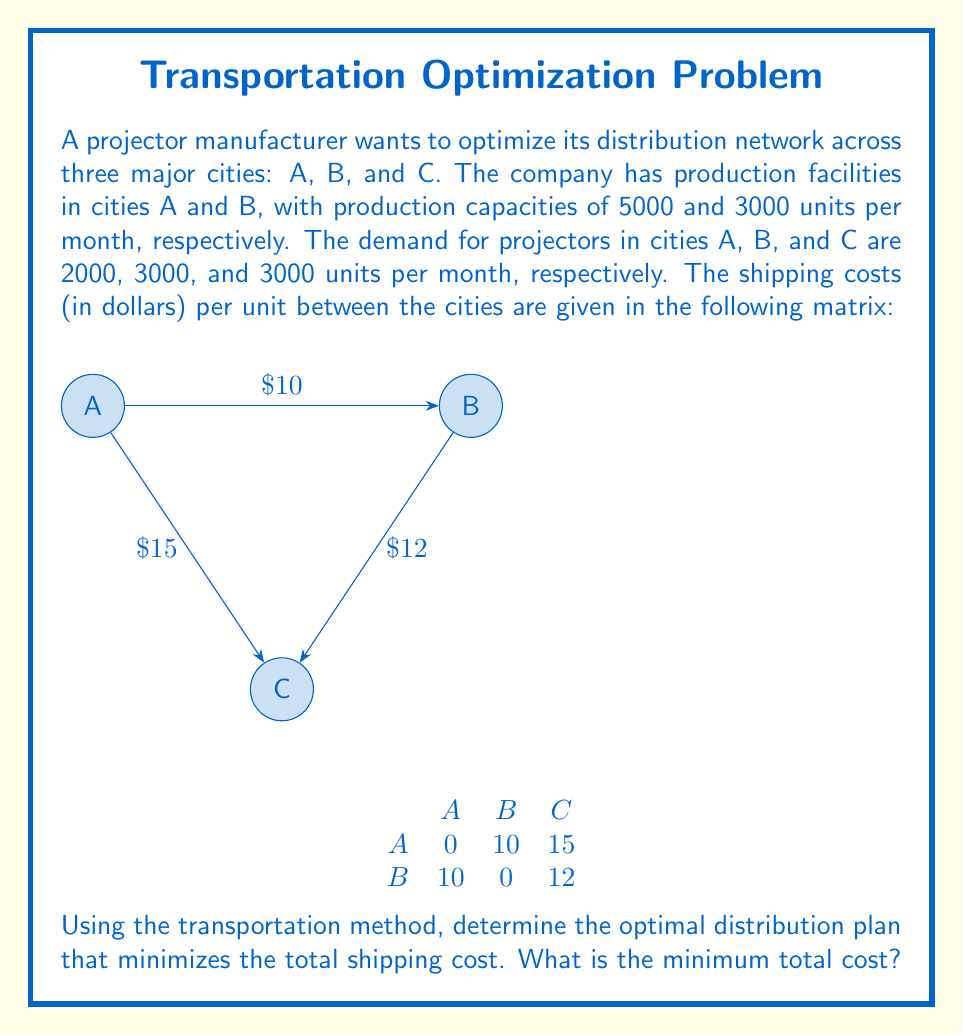Give your solution to this math problem. To solve this problem, we'll use the transportation method, which is a linear programming technique. Let's follow these steps:

1) First, let's set up the initial transportation table:

   $$
   \begin{array}{c|ccc|c}
    & A & B & C & \text{Supply} \\
   \hline
   A & 0 & 10 & 15 & 5000 \\
   B & 10 & 0 & 12 & 3000 \\
   \hline
   \text{Demand} & 2000 & 3000 & 3000 & 8000
   \end{array}
   $$

2) We'll use the Northwest Corner method to find an initial feasible solution:

   $$
   \begin{array}{c|ccc|c}
    & A & B & C & \text{Supply} \\
   \hline
   A & 2000 & 3000 & 0 & 5000 \\
   B & 0 & 0 & 3000 & 3000 \\
   \hline
   \text{Demand} & 2000 & 3000 & 3000 & 8000
   \end{array}
   $$

3) Now, let's calculate the initial cost:
   $2000 \times 0 + 3000 \times 10 + 3000 \times 12 = 66,000$

4) Next, we need to check if this solution is optimal. We'll use the stepping stone method:
   - Calculate ui and vj values
   - Find the opportunity cost for empty cells

5) After calculations, we find that the cell B to A has a negative opportunity cost of -10. This means we can improve the solution.

6) We make the following adjustment:
   - Add 2000 to B to A
   - Subtract 2000 from A to A
   - Add 2000 to A to C
   - Subtract 2000 from B to C

7) Our new solution looks like this:

   $$
   \begin{array}{c|ccc|c}
    & A & B & C & \text{Supply} \\
   \hline
   A & 0 & 3000 & 2000 & 5000 \\
   B & 2000 & 0 & 1000 & 3000 \\
   \hline
   \text{Demand} & 2000 & 3000 & 3000 & 8000
   \end{array}
   $$

8) Calculate the new cost:
   $3000 \times 10 + 2000 \times 15 + 2000 \times 10 + 1000 \times 12 = 62,000$

9) Checking again, we find no negative opportunity costs, so this solution is optimal.
Answer: $62,000 